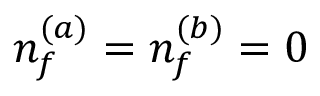Convert formula to latex. <formula><loc_0><loc_0><loc_500><loc_500>n _ { f } ^ { ( a ) } = n _ { f } ^ { ( b ) } = 0</formula> 